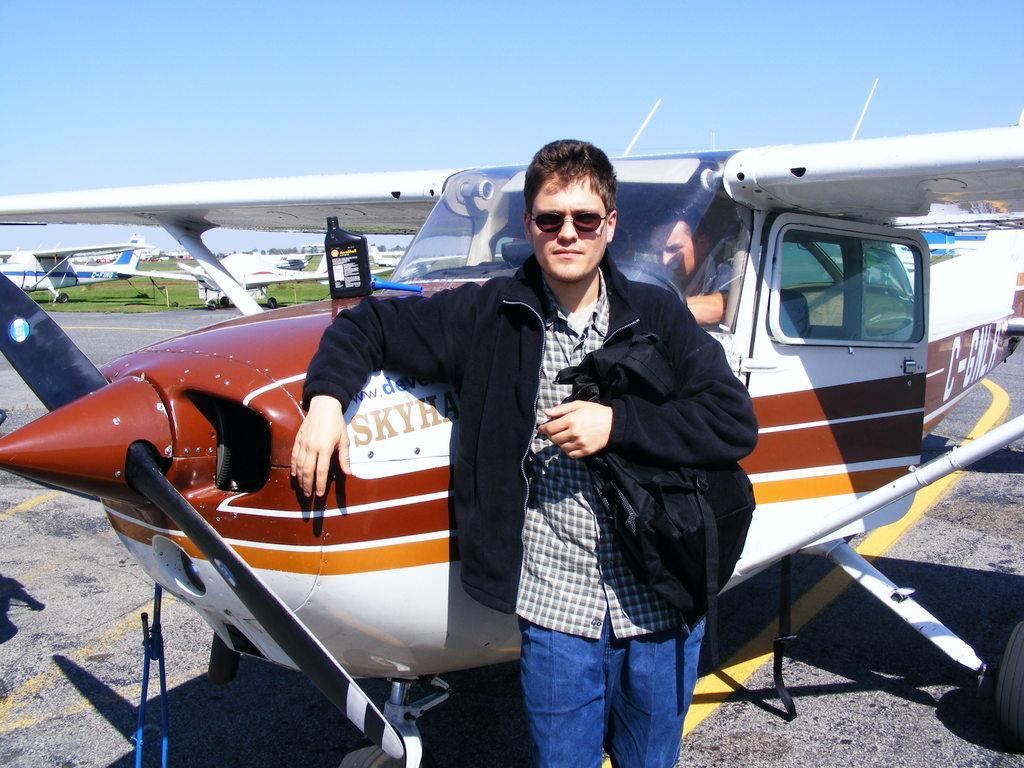Could you give a brief overview of what you see in this image? In this picture we can see some planes and one person is standing side of a plane and holding bag. 